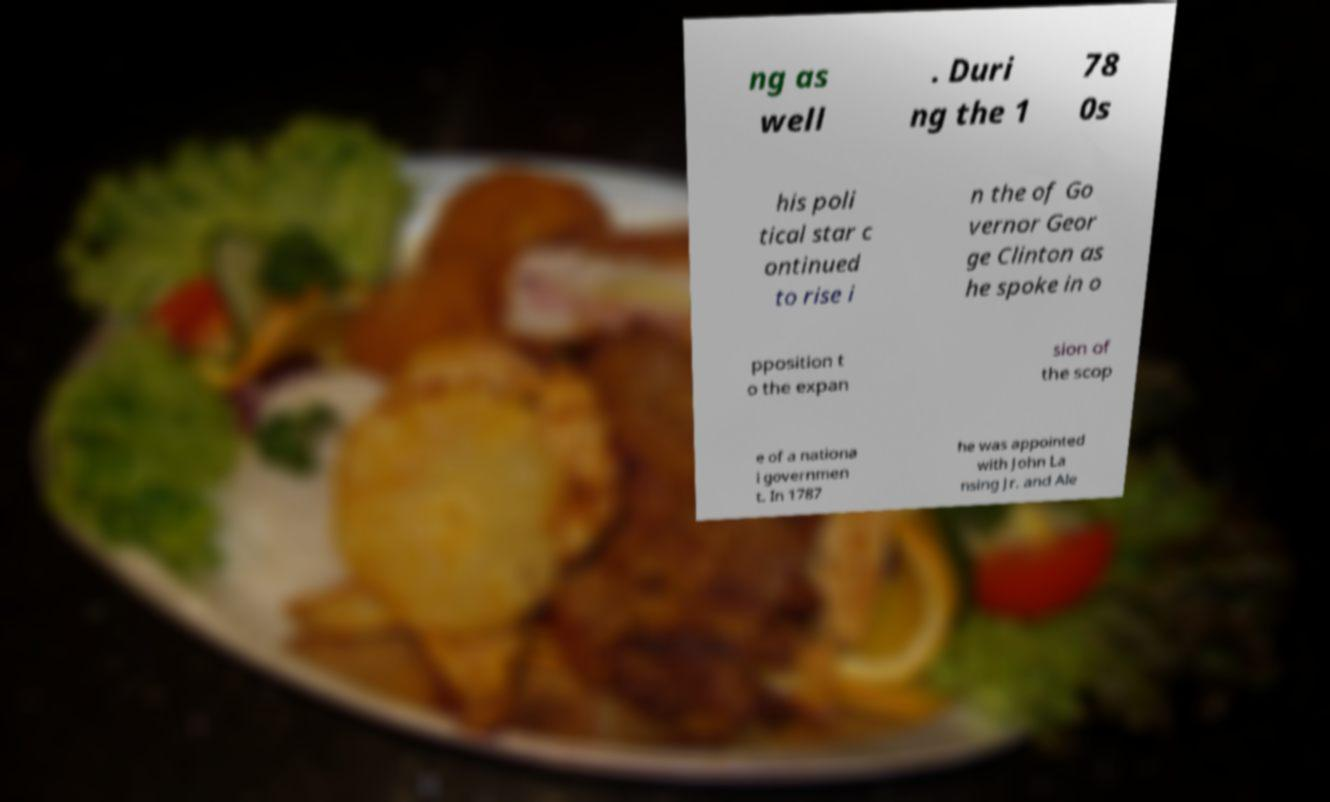Could you extract and type out the text from this image? ng as well . Duri ng the 1 78 0s his poli tical star c ontinued to rise i n the of Go vernor Geor ge Clinton as he spoke in o pposition t o the expan sion of the scop e of a nationa l governmen t. In 1787 he was appointed with John La nsing Jr. and Ale 